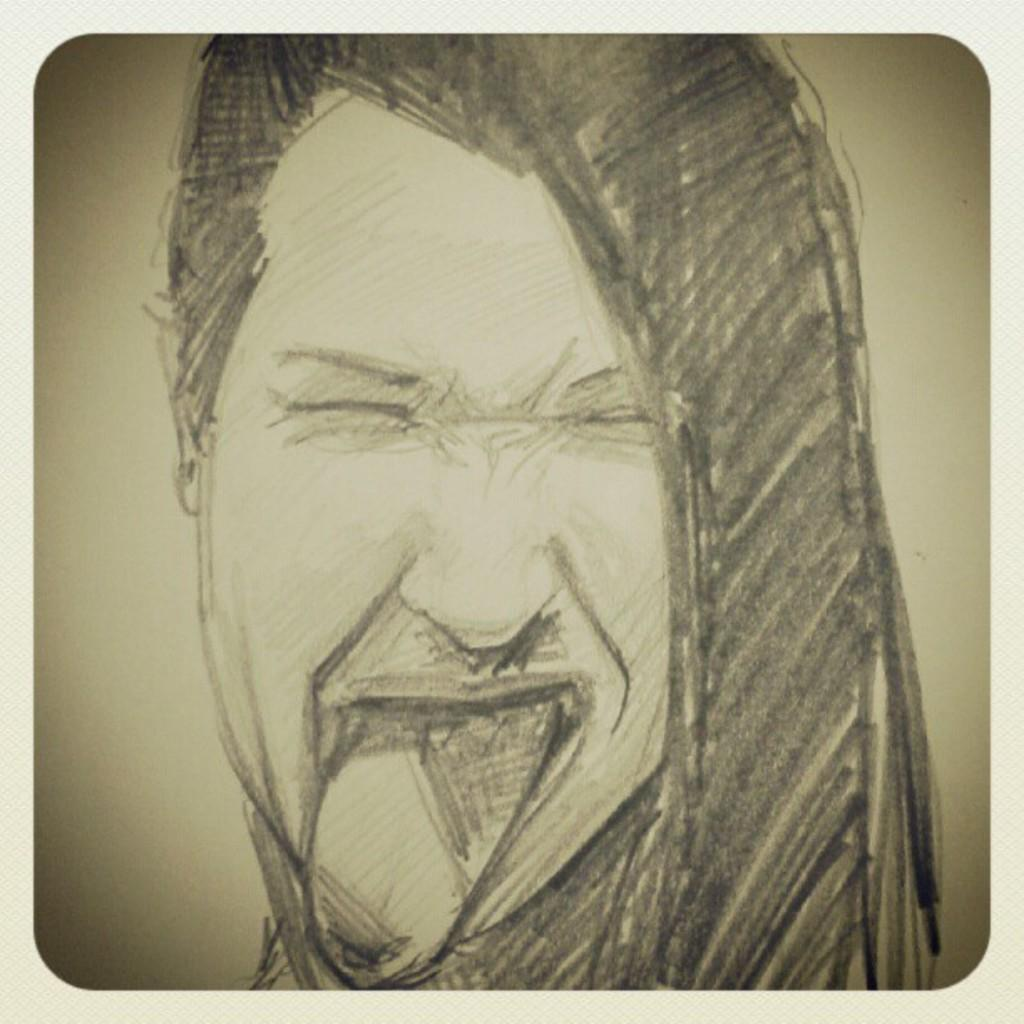What type of object is present in the image? The image contains an art piece. What is the subject of the art piece? The art piece depicts a person's face. What type of glove is being used by the person in the art piece? There is no glove present in the art piece; it depicts a person's face. 